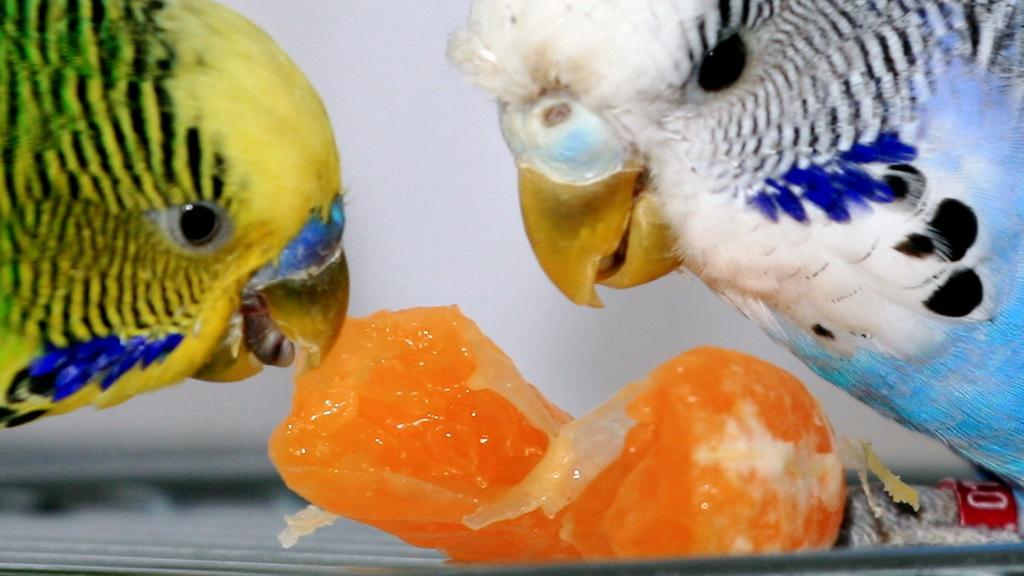Please provide a concise description of this image. In the foreground of this image, There are two parrots and one is eating a piece of an orange. 